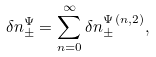<formula> <loc_0><loc_0><loc_500><loc_500>\delta n ^ { \Psi } _ { \pm } = \sum _ { n = 0 } ^ { \infty } \delta n ^ { \Psi \, ( n , 2 ) } _ { \pm } ,</formula> 